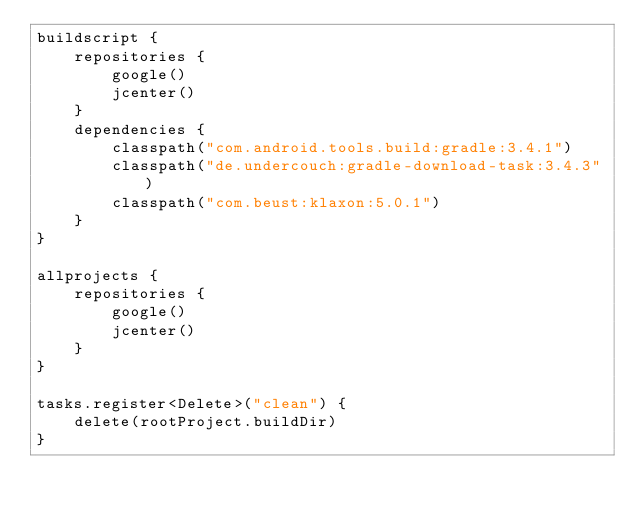<code> <loc_0><loc_0><loc_500><loc_500><_Kotlin_>buildscript {
    repositories {
        google()
        jcenter()
    }
    dependencies {
        classpath("com.android.tools.build:gradle:3.4.1")
        classpath("de.undercouch:gradle-download-task:3.4.3")
        classpath("com.beust:klaxon:5.0.1")
    }
}

allprojects {
    repositories {
        google()
        jcenter()
    }
}

tasks.register<Delete>("clean") {
    delete(rootProject.buildDir)
}
</code> 